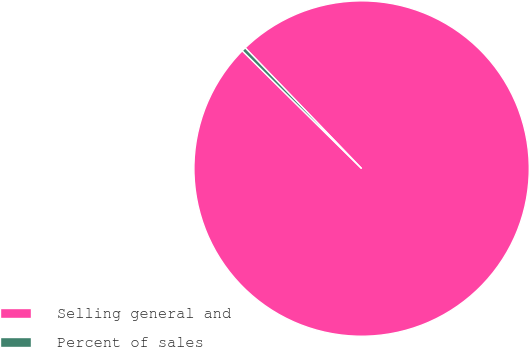Convert chart. <chart><loc_0><loc_0><loc_500><loc_500><pie_chart><fcel>Selling general and<fcel>Percent of sales<nl><fcel>99.61%<fcel>0.39%<nl></chart> 